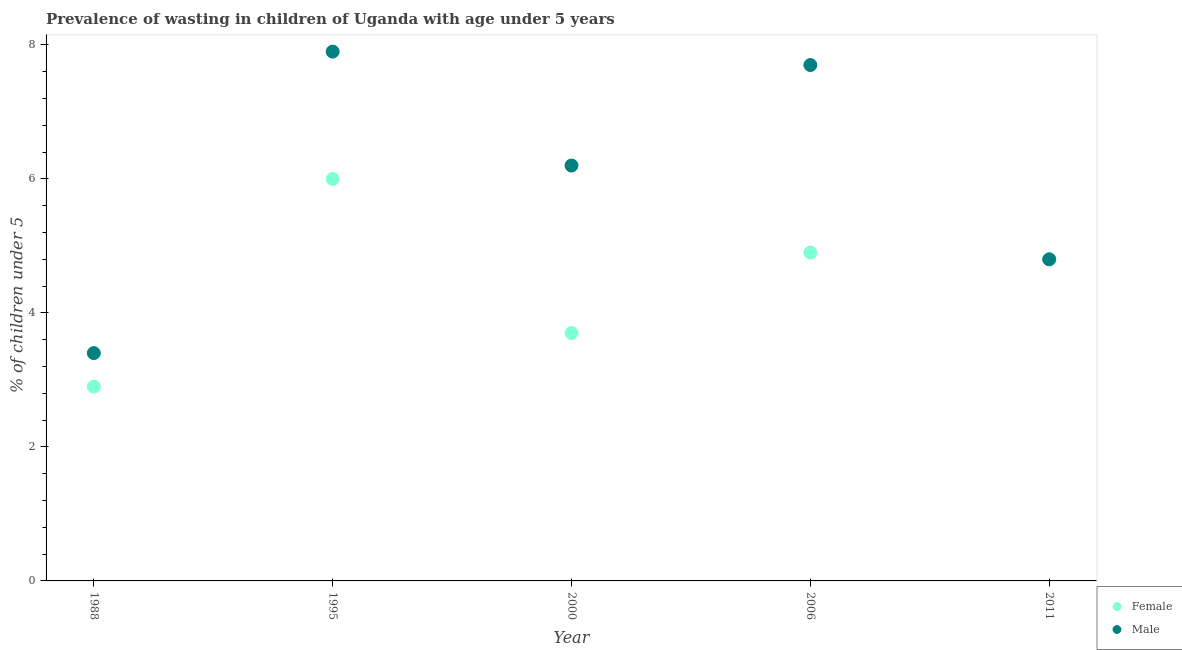What is the percentage of undernourished male children in 1995?
Make the answer very short. 7.9. Across all years, what is the minimum percentage of undernourished female children?
Ensure brevity in your answer.  2.9. In which year was the percentage of undernourished female children maximum?
Give a very brief answer. 1995. What is the total percentage of undernourished female children in the graph?
Offer a terse response. 22.3. What is the difference between the percentage of undernourished male children in 2000 and that in 2011?
Offer a very short reply. 1.4. What is the difference between the percentage of undernourished male children in 2000 and the percentage of undernourished female children in 1995?
Offer a very short reply. 0.2. What is the average percentage of undernourished male children per year?
Give a very brief answer. 6. In how many years, is the percentage of undernourished female children greater than 6.4 %?
Offer a terse response. 0. What is the ratio of the percentage of undernourished male children in 1995 to that in 2006?
Your answer should be very brief. 1.03. Is the percentage of undernourished male children in 1995 less than that in 2000?
Make the answer very short. No. Is the difference between the percentage of undernourished female children in 1988 and 2011 greater than the difference between the percentage of undernourished male children in 1988 and 2011?
Offer a very short reply. No. What is the difference between the highest and the second highest percentage of undernourished male children?
Your response must be concise. 0.2. What is the difference between the highest and the lowest percentage of undernourished female children?
Make the answer very short. 3.1. Is the sum of the percentage of undernourished female children in 1995 and 2011 greater than the maximum percentage of undernourished male children across all years?
Your response must be concise. Yes. Does the percentage of undernourished female children monotonically increase over the years?
Offer a very short reply. No. Is the percentage of undernourished male children strictly greater than the percentage of undernourished female children over the years?
Make the answer very short. No. Is the percentage of undernourished female children strictly less than the percentage of undernourished male children over the years?
Provide a short and direct response. No. How many dotlines are there?
Provide a short and direct response. 2. Does the graph contain any zero values?
Your answer should be compact. No. Does the graph contain grids?
Offer a very short reply. No. Where does the legend appear in the graph?
Offer a terse response. Bottom right. What is the title of the graph?
Keep it short and to the point. Prevalence of wasting in children of Uganda with age under 5 years. Does "Mineral" appear as one of the legend labels in the graph?
Your response must be concise. No. What is the label or title of the Y-axis?
Your answer should be compact.  % of children under 5. What is the  % of children under 5 of Female in 1988?
Offer a terse response. 2.9. What is the  % of children under 5 in Male in 1988?
Make the answer very short. 3.4. What is the  % of children under 5 in Female in 1995?
Offer a very short reply. 6. What is the  % of children under 5 in Male in 1995?
Make the answer very short. 7.9. What is the  % of children under 5 of Female in 2000?
Provide a succinct answer. 3.7. What is the  % of children under 5 of Male in 2000?
Provide a short and direct response. 6.2. What is the  % of children under 5 in Female in 2006?
Give a very brief answer. 4.9. What is the  % of children under 5 of Male in 2006?
Offer a very short reply. 7.7. What is the  % of children under 5 of Female in 2011?
Keep it short and to the point. 4.8. What is the  % of children under 5 of Male in 2011?
Make the answer very short. 4.8. Across all years, what is the maximum  % of children under 5 in Male?
Provide a short and direct response. 7.9. Across all years, what is the minimum  % of children under 5 in Female?
Give a very brief answer. 2.9. Across all years, what is the minimum  % of children under 5 in Male?
Give a very brief answer. 3.4. What is the total  % of children under 5 in Female in the graph?
Your response must be concise. 22.3. What is the difference between the  % of children under 5 in Female in 1988 and that in 1995?
Provide a succinct answer. -3.1. What is the difference between the  % of children under 5 in Male in 1988 and that in 2000?
Make the answer very short. -2.8. What is the difference between the  % of children under 5 in Female in 1988 and that in 2006?
Provide a succinct answer. -2. What is the difference between the  % of children under 5 of Male in 1988 and that in 2006?
Provide a succinct answer. -4.3. What is the difference between the  % of children under 5 of Female in 1988 and that in 2011?
Provide a short and direct response. -1.9. What is the difference between the  % of children under 5 of Female in 1995 and that in 2000?
Ensure brevity in your answer.  2.3. What is the difference between the  % of children under 5 in Male in 1995 and that in 2006?
Offer a terse response. 0.2. What is the difference between the  % of children under 5 in Female in 2000 and that in 2011?
Give a very brief answer. -1.1. What is the difference between the  % of children under 5 in Male in 2000 and that in 2011?
Make the answer very short. 1.4. What is the difference between the  % of children under 5 in Male in 2006 and that in 2011?
Offer a terse response. 2.9. What is the difference between the  % of children under 5 in Female in 1988 and the  % of children under 5 in Male in 1995?
Offer a very short reply. -5. What is the difference between the  % of children under 5 of Female in 1988 and the  % of children under 5 of Male in 2000?
Your answer should be compact. -3.3. What is the difference between the  % of children under 5 in Female in 1995 and the  % of children under 5 in Male in 2006?
Offer a terse response. -1.7. What is the difference between the  % of children under 5 in Female in 1995 and the  % of children under 5 in Male in 2011?
Provide a succinct answer. 1.2. What is the difference between the  % of children under 5 in Female in 2000 and the  % of children under 5 in Male in 2006?
Your response must be concise. -4. What is the difference between the  % of children under 5 of Female in 2000 and the  % of children under 5 of Male in 2011?
Give a very brief answer. -1.1. What is the difference between the  % of children under 5 of Female in 2006 and the  % of children under 5 of Male in 2011?
Offer a very short reply. 0.1. What is the average  % of children under 5 of Female per year?
Provide a succinct answer. 4.46. In the year 1995, what is the difference between the  % of children under 5 of Female and  % of children under 5 of Male?
Give a very brief answer. -1.9. In the year 2006, what is the difference between the  % of children under 5 of Female and  % of children under 5 of Male?
Provide a succinct answer. -2.8. In the year 2011, what is the difference between the  % of children under 5 of Female and  % of children under 5 of Male?
Keep it short and to the point. 0. What is the ratio of the  % of children under 5 of Female in 1988 to that in 1995?
Your answer should be very brief. 0.48. What is the ratio of the  % of children under 5 of Male in 1988 to that in 1995?
Offer a terse response. 0.43. What is the ratio of the  % of children under 5 in Female in 1988 to that in 2000?
Your answer should be compact. 0.78. What is the ratio of the  % of children under 5 in Male in 1988 to that in 2000?
Keep it short and to the point. 0.55. What is the ratio of the  % of children under 5 in Female in 1988 to that in 2006?
Offer a terse response. 0.59. What is the ratio of the  % of children under 5 of Male in 1988 to that in 2006?
Ensure brevity in your answer.  0.44. What is the ratio of the  % of children under 5 of Female in 1988 to that in 2011?
Give a very brief answer. 0.6. What is the ratio of the  % of children under 5 of Male in 1988 to that in 2011?
Offer a terse response. 0.71. What is the ratio of the  % of children under 5 of Female in 1995 to that in 2000?
Give a very brief answer. 1.62. What is the ratio of the  % of children under 5 of Male in 1995 to that in 2000?
Make the answer very short. 1.27. What is the ratio of the  % of children under 5 of Female in 1995 to that in 2006?
Keep it short and to the point. 1.22. What is the ratio of the  % of children under 5 in Female in 1995 to that in 2011?
Offer a terse response. 1.25. What is the ratio of the  % of children under 5 in Male in 1995 to that in 2011?
Provide a short and direct response. 1.65. What is the ratio of the  % of children under 5 in Female in 2000 to that in 2006?
Offer a very short reply. 0.76. What is the ratio of the  % of children under 5 in Male in 2000 to that in 2006?
Give a very brief answer. 0.81. What is the ratio of the  % of children under 5 in Female in 2000 to that in 2011?
Your answer should be compact. 0.77. What is the ratio of the  % of children under 5 of Male in 2000 to that in 2011?
Offer a terse response. 1.29. What is the ratio of the  % of children under 5 in Female in 2006 to that in 2011?
Offer a terse response. 1.02. What is the ratio of the  % of children under 5 of Male in 2006 to that in 2011?
Give a very brief answer. 1.6. What is the difference between the highest and the lowest  % of children under 5 of Female?
Offer a terse response. 3.1. What is the difference between the highest and the lowest  % of children under 5 of Male?
Offer a very short reply. 4.5. 